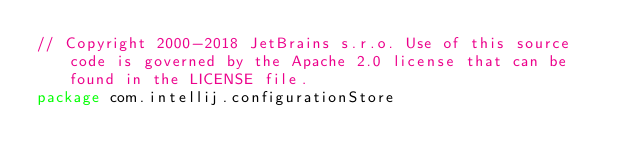Convert code to text. <code><loc_0><loc_0><loc_500><loc_500><_Kotlin_>// Copyright 2000-2018 JetBrains s.r.o. Use of this source code is governed by the Apache 2.0 license that can be found in the LICENSE file.
package com.intellij.configurationStore
</code> 